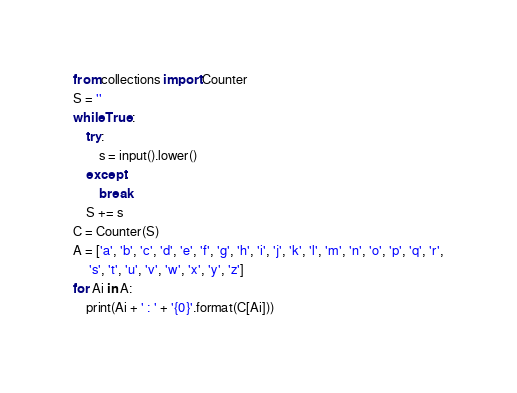<code> <loc_0><loc_0><loc_500><loc_500><_Python_>from collections import Counter
S = ''
while True:
    try:
        s = input().lower()
    except:
        break
    S += s
C = Counter(S)
A = ['a', 'b', 'c', 'd', 'e', 'f', 'g', 'h', 'i', 'j', 'k', 'l', 'm', 'n', 'o', 'p', 'q', 'r',
     's', 't', 'u', 'v', 'w', 'x', 'y', 'z']
for Ai in A:
    print(Ai + ' : ' + '{0}'.format(C[Ai]))
</code> 